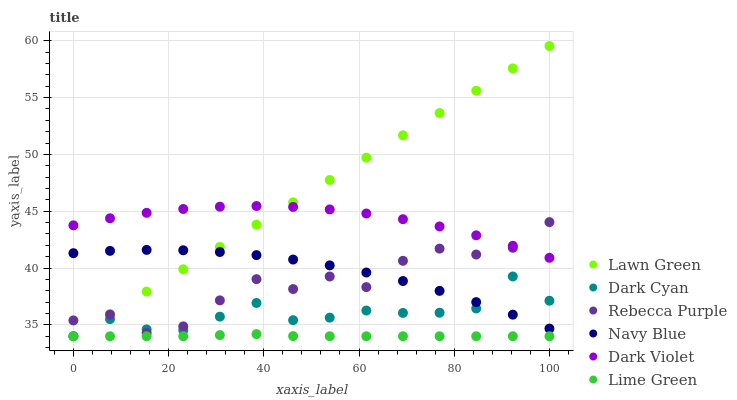Does Lime Green have the minimum area under the curve?
Answer yes or no. Yes. Does Lawn Green have the maximum area under the curve?
Answer yes or no. Yes. Does Navy Blue have the minimum area under the curve?
Answer yes or no. No. Does Navy Blue have the maximum area under the curve?
Answer yes or no. No. Is Lawn Green the smoothest?
Answer yes or no. Yes. Is Rebecca Purple the roughest?
Answer yes or no. Yes. Is Navy Blue the smoothest?
Answer yes or no. No. Is Navy Blue the roughest?
Answer yes or no. No. Does Lawn Green have the lowest value?
Answer yes or no. Yes. Does Navy Blue have the lowest value?
Answer yes or no. No. Does Lawn Green have the highest value?
Answer yes or no. Yes. Does Navy Blue have the highest value?
Answer yes or no. No. Is Lime Green less than Rebecca Purple?
Answer yes or no. Yes. Is Rebecca Purple greater than Lime Green?
Answer yes or no. Yes. Does Navy Blue intersect Lawn Green?
Answer yes or no. Yes. Is Navy Blue less than Lawn Green?
Answer yes or no. No. Is Navy Blue greater than Lawn Green?
Answer yes or no. No. Does Lime Green intersect Rebecca Purple?
Answer yes or no. No. 